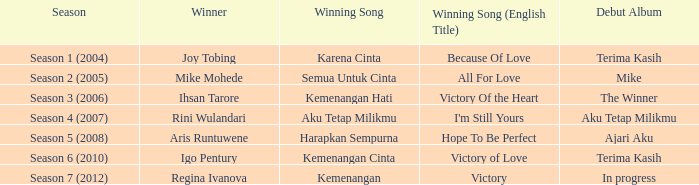Which triumphant tune was sung by aku tetap milikmu? I'm Still Yours. 